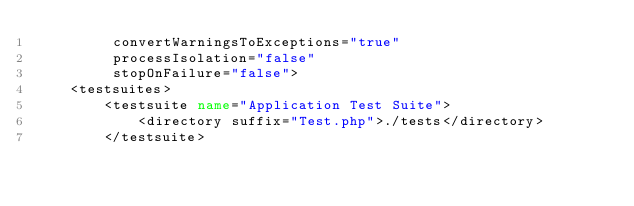<code> <loc_0><loc_0><loc_500><loc_500><_XML_>         convertWarningsToExceptions="true"
         processIsolation="false"
         stopOnFailure="false">
    <testsuites>
        <testsuite name="Application Test Suite">
            <directory suffix="Test.php">./tests</directory>
        </testsuite></code> 